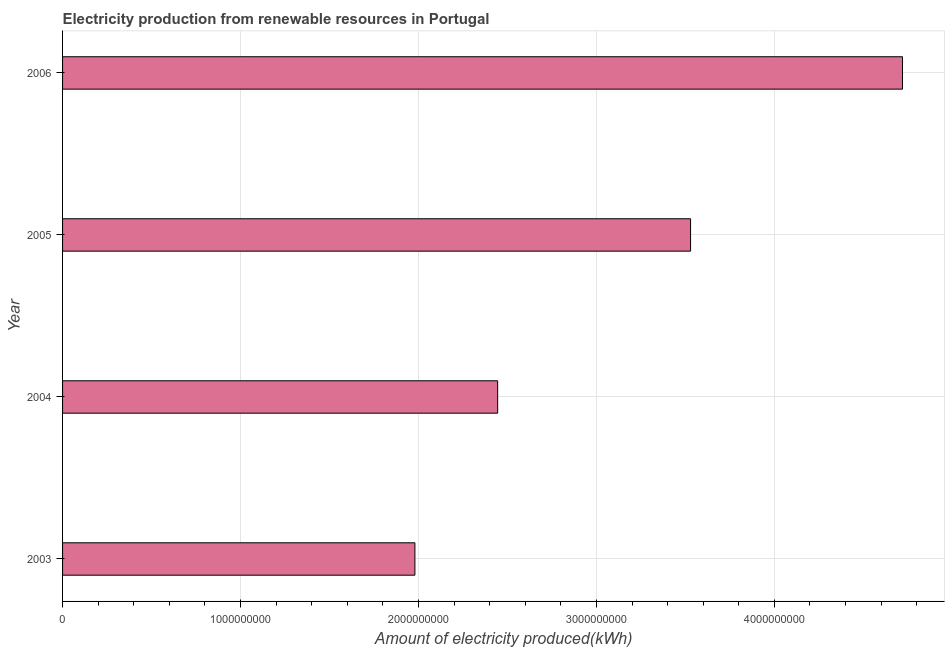What is the title of the graph?
Provide a short and direct response. Electricity production from renewable resources in Portugal. What is the label or title of the X-axis?
Your answer should be compact. Amount of electricity produced(kWh). What is the amount of electricity produced in 2003?
Make the answer very short. 1.98e+09. Across all years, what is the maximum amount of electricity produced?
Keep it short and to the point. 4.72e+09. Across all years, what is the minimum amount of electricity produced?
Your answer should be very brief. 1.98e+09. In which year was the amount of electricity produced maximum?
Your answer should be compact. 2006. In which year was the amount of electricity produced minimum?
Keep it short and to the point. 2003. What is the sum of the amount of electricity produced?
Your answer should be compact. 1.27e+1. What is the difference between the amount of electricity produced in 2003 and 2004?
Keep it short and to the point. -4.65e+08. What is the average amount of electricity produced per year?
Your answer should be compact. 3.17e+09. What is the median amount of electricity produced?
Ensure brevity in your answer.  2.99e+09. In how many years, is the amount of electricity produced greater than 3000000000 kWh?
Offer a terse response. 2. Do a majority of the years between 2003 and 2006 (inclusive) have amount of electricity produced greater than 4000000000 kWh?
Your answer should be very brief. No. What is the ratio of the amount of electricity produced in 2005 to that in 2006?
Provide a succinct answer. 0.75. Is the difference between the amount of electricity produced in 2005 and 2006 greater than the difference between any two years?
Offer a terse response. No. What is the difference between the highest and the second highest amount of electricity produced?
Your answer should be very brief. 1.19e+09. What is the difference between the highest and the lowest amount of electricity produced?
Provide a short and direct response. 2.74e+09. How many bars are there?
Your answer should be very brief. 4. Are all the bars in the graph horizontal?
Keep it short and to the point. Yes. What is the Amount of electricity produced(kWh) in 2003?
Your answer should be very brief. 1.98e+09. What is the Amount of electricity produced(kWh) of 2004?
Your answer should be compact. 2.44e+09. What is the Amount of electricity produced(kWh) of 2005?
Keep it short and to the point. 3.53e+09. What is the Amount of electricity produced(kWh) in 2006?
Your response must be concise. 4.72e+09. What is the difference between the Amount of electricity produced(kWh) in 2003 and 2004?
Offer a very short reply. -4.65e+08. What is the difference between the Amount of electricity produced(kWh) in 2003 and 2005?
Ensure brevity in your answer.  -1.55e+09. What is the difference between the Amount of electricity produced(kWh) in 2003 and 2006?
Provide a short and direct response. -2.74e+09. What is the difference between the Amount of electricity produced(kWh) in 2004 and 2005?
Offer a terse response. -1.08e+09. What is the difference between the Amount of electricity produced(kWh) in 2004 and 2006?
Give a very brief answer. -2.28e+09. What is the difference between the Amount of electricity produced(kWh) in 2005 and 2006?
Provide a succinct answer. -1.19e+09. What is the ratio of the Amount of electricity produced(kWh) in 2003 to that in 2004?
Provide a short and direct response. 0.81. What is the ratio of the Amount of electricity produced(kWh) in 2003 to that in 2005?
Offer a very short reply. 0.56. What is the ratio of the Amount of electricity produced(kWh) in 2003 to that in 2006?
Provide a short and direct response. 0.42. What is the ratio of the Amount of electricity produced(kWh) in 2004 to that in 2005?
Keep it short and to the point. 0.69. What is the ratio of the Amount of electricity produced(kWh) in 2004 to that in 2006?
Give a very brief answer. 0.52. What is the ratio of the Amount of electricity produced(kWh) in 2005 to that in 2006?
Offer a very short reply. 0.75. 